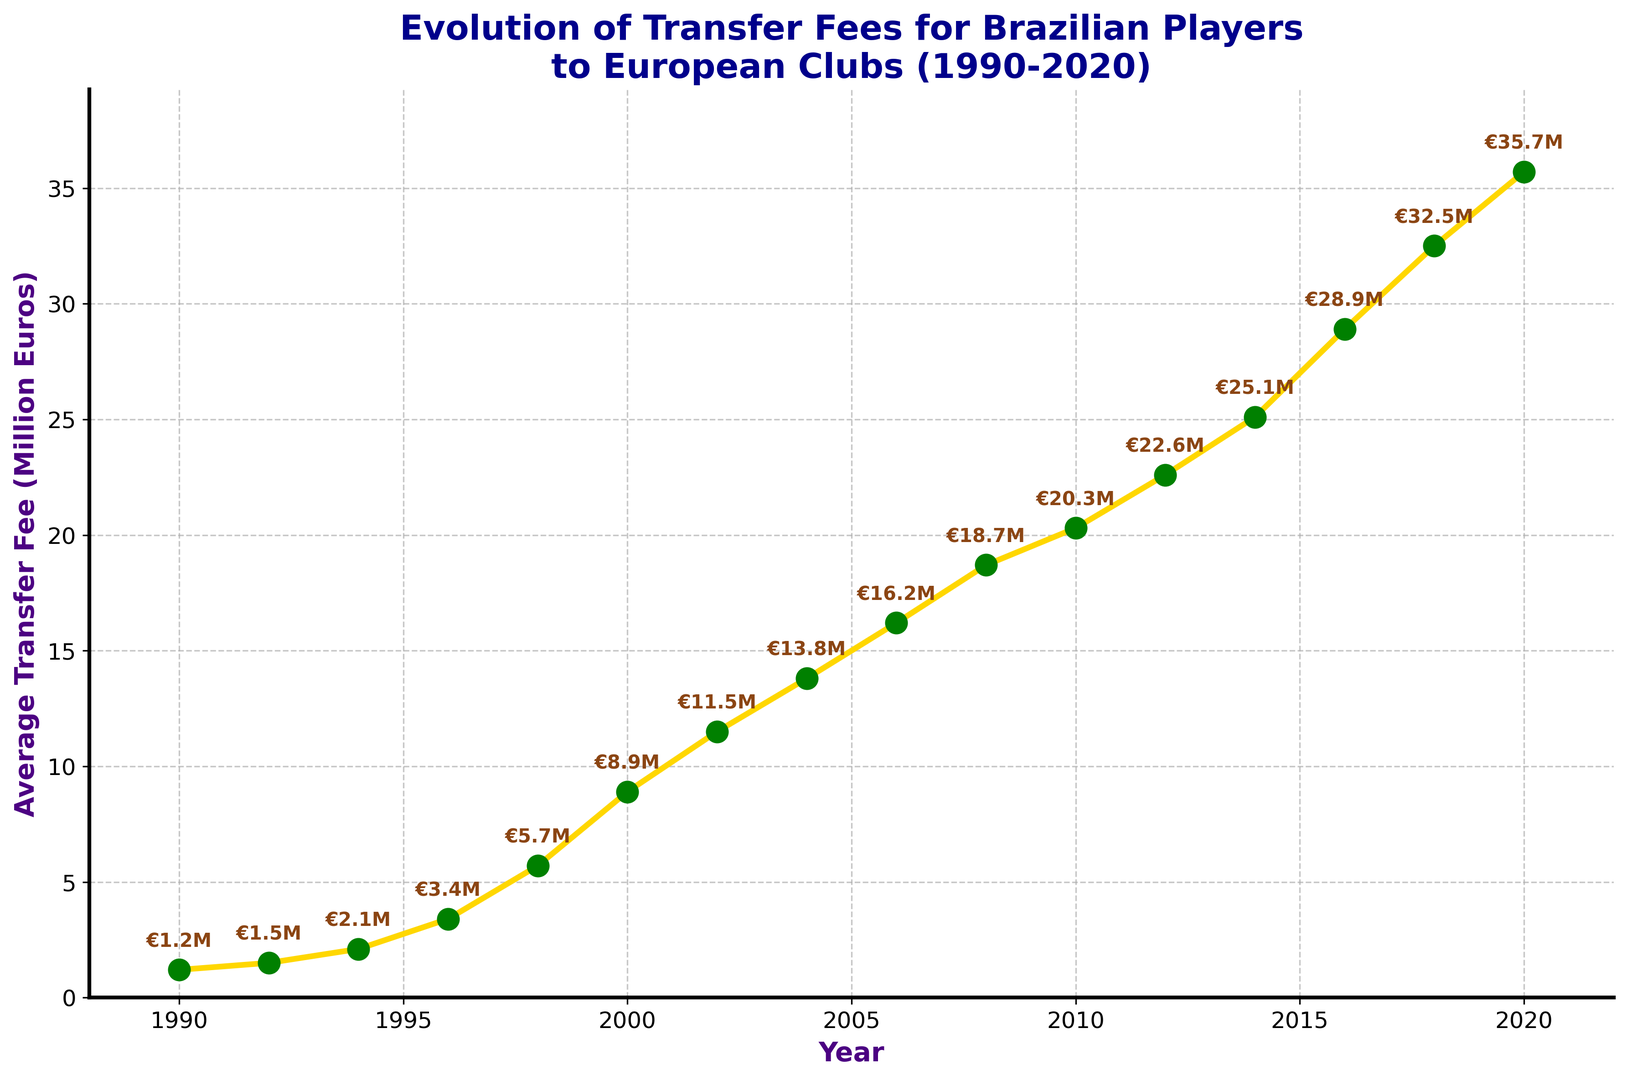What's the average transfer fee in the year 2006? Find the data point corresponding to the year 2006 on the x-axis and read the value on the y-axis. The average transfer fee is €16.2 million.
Answer: €16.2 million In which year did the average transfer fee exceed €20 million for the first time? Find the year on the x-axis where the average transfer fee crosses the €20 million mark on the y-axis. That year is 2010.
Answer: 2010 By how much did the average transfer fee increase from 1998 to 2000? Locate the data points for 1998 and 2000 on the x-axis and note the corresponding fees on the y-axis. Calculate the difference: €8.9 million (2000) - €5.7 million (1998) = €3.2 million.
Answer: €3.2 million What was the average transfer fee trend between 2014 and 2018? Observe the line segment connecting the years 2014 and 2018 on the x-axis. The average transfer fee rose from €25.1 million in 2014 to €32.5 million in 2018.
Answer: Increasing How does the average transfer fee in 2020 compare to that in 2002? Find the data points for 2020 and 2002 on the x-axis and compare their values on the y-axis. The fee in 2020 (€35.7 million) is higher than in 2002 (€11.5 million).
Answer: Higher in 2020 What is the total sum of the average transfer fees in 2008 and 2010? Locate the data points for 2008 and 2010 on the x-axis and sum their values. The fees are €18.7 million and €20.3 million, respectively. The total is €18.7 million + €20.3 million = €39 million.
Answer: €39 million Which period saw the largest increase in transfer fees, 1990-2000 or 2010-2020? Compare the increase in transfer fees over the two periods. For 1990-2000: €8.9 million - €1.2 million = €7.7 million. For 2010-2020: €35.7 million - €20.3 million = €15.4 million. The increase is larger in 2010-2020.
Answer: 2010-2020 What is the visual representation (color) of the line and markers in the plot? Observe the colors used for the line (yellow) and the markers (green with green edges).
Answer: Yellow line and green markers How many years did it take for the transfer fee to triple from its value in 1992? Note the value in 1992 (€1.5 million) and find the year where the fee is approximately three times that value (€4.5 million). This occurs in 1998 (€5.7 million). It took 1998 - 1992 = 6 years.
Answer: 6 years 